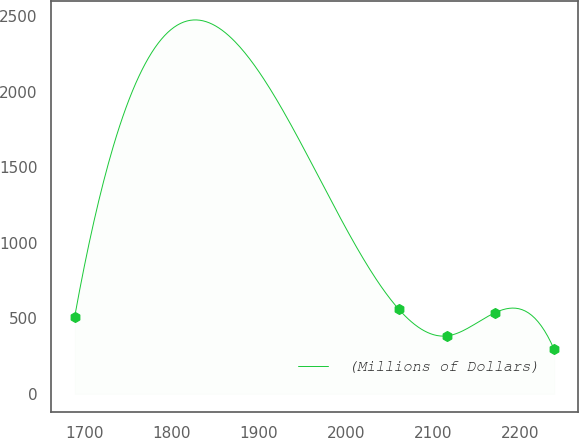<chart> <loc_0><loc_0><loc_500><loc_500><line_chart><ecel><fcel>(Millions of Dollars)<nl><fcel>1688.64<fcel>511.28<nl><fcel>2060.97<fcel>560.3<nl><fcel>2116.06<fcel>383.09<nl><fcel>2171.15<fcel>535.79<nl><fcel>2239.51<fcel>294.04<nl></chart> 